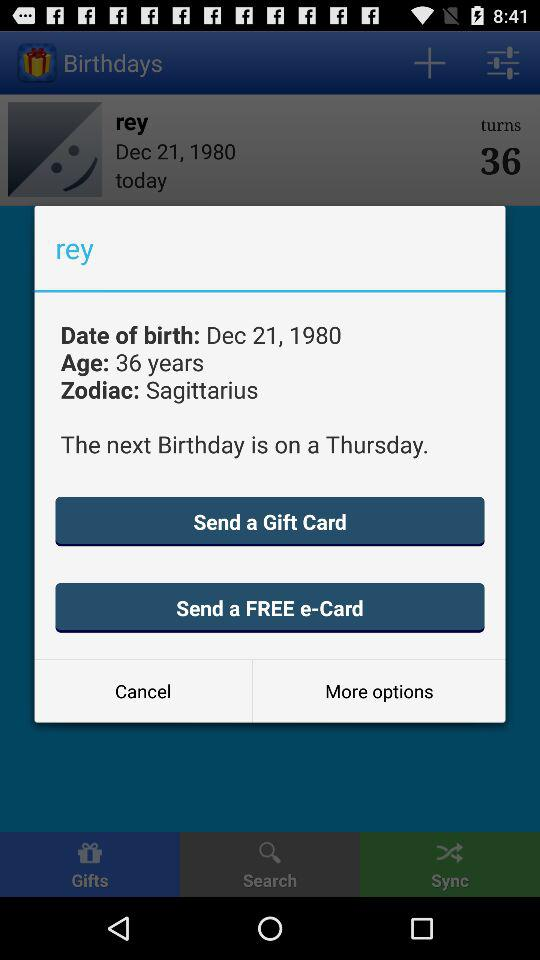What is the name of the person? The name is rey. 